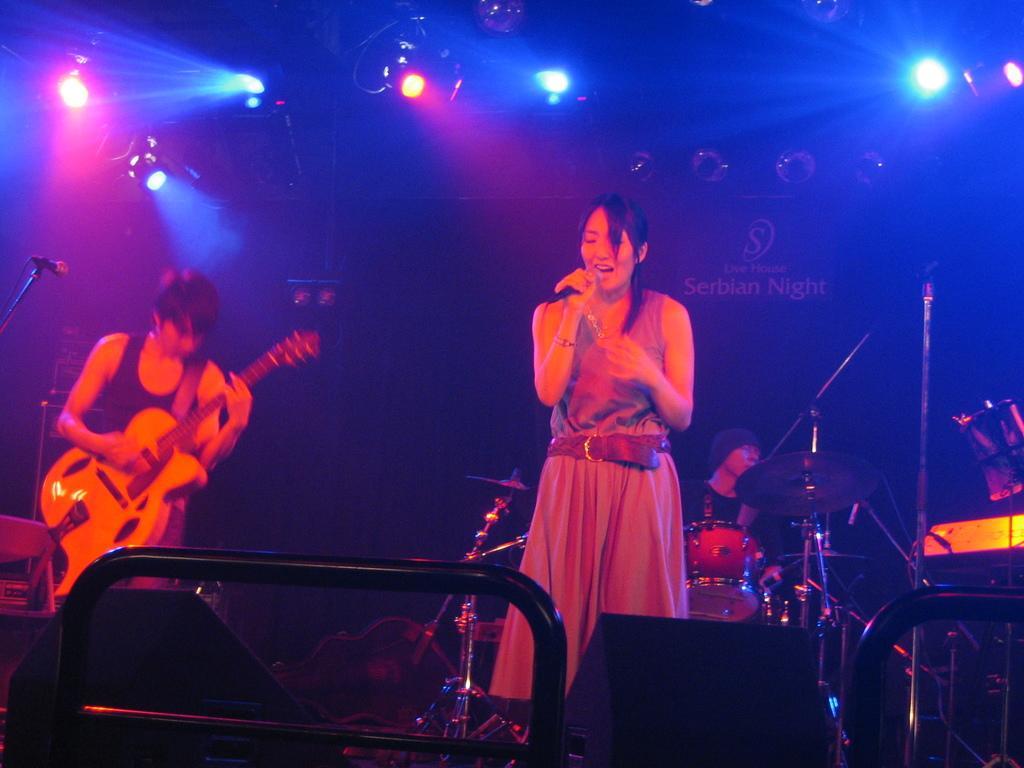Please provide a concise description of this image. In this picture there are two woman, one of them is singing and she has a microphone in her right and and the and the woman is playing the guitar and are some disco lights 